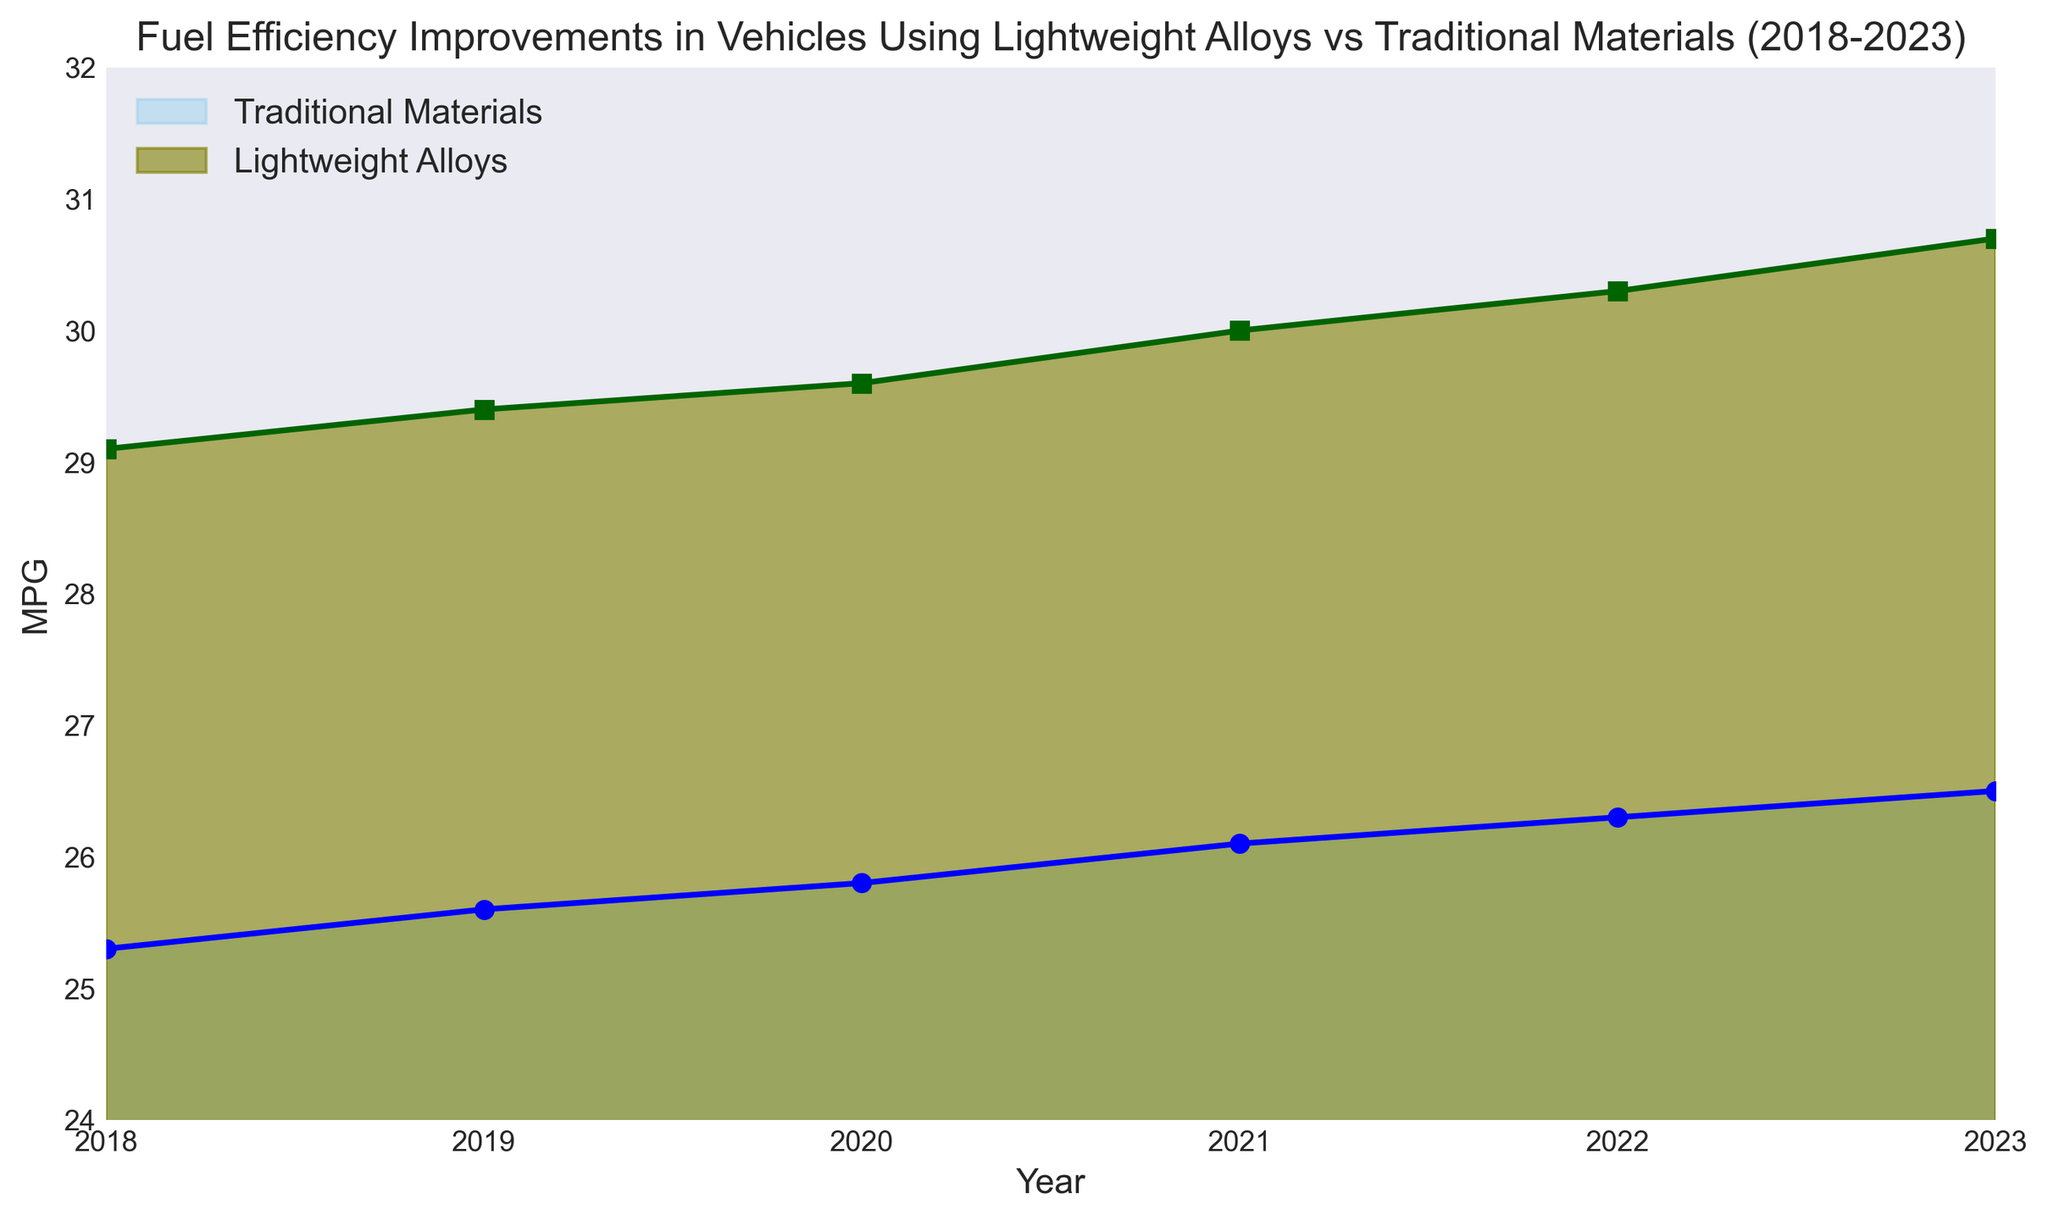What is the overall trend for fuel efficiency in vehicles using lightweight alloys over the past 5 years? The chart shows a consistent increase in MPG for lightweight alloys from 29.1 in 2018 to 30.7 in 2023. This indicates an upward trend in fuel efficiency for vehicles using lightweight alloys over the specified time period.
Answer: Upward trend What was the difference in MPG between traditional materials and lightweight alloys in the year 2020? In 2020, the MPG for traditional materials was 25.8 and for lightweight alloys, it was 29.6. The difference is calculated as 29.6 - 25.8.
Answer: 3.8 MPG Which year saw the greatest increase in MPG for lightweight alloys compared to its previous year? By comparing the yearly increases: 2018 to 2019 (+0.3), 2019 to 2020 (+0.2), 2020 to 2021 (+0.4), 2021 to 2022 (+0.3), and 2022 to 2023 (+0.4), the largest increase was observed from 2020 to 2021 and 2022 to 2023, both with an increase of 0.4 MPG.
Answer: 2020 to 2021 and 2022 to 2023 What is the average MPG for traditional materials from 2018 to 2023? Sum the MPG values for traditional materials for each year (25.3 + 25.6 + 25.8 + 26.1 + 26.3 + 26.5) which equals 155.6, then divide by the number of years (6).
Answer: 25.93 MPG In 2023, how much more fuel efficient were the vehicles using lightweight alloys compared to those using traditional materials? The MPG for lightweight alloys in 2023 was 30.7, and for traditional materials, it was 26.5. The difference is calculated as 30.7 - 26.5.
Answer: 4.2 MPG Which material demonstrated a more significant improvement in fuel efficiency over the 5 years? Calculate the difference in MPG for each material from 2018 to 2023: Traditional materials improved from 25.3 to 26.5, an increase of 1.2 MPG. Lightweight alloys improved from 29.1 to 30.7, an increase of 1.6 MPG.
Answer: Lightweight alloys Visually, which material's area appears larger on the chart and why? The area representing lightweight alloys appears larger due to both higher initial MPG values and a greater rate of increase compared to traditional materials.
Answer: Lightweight alloys 